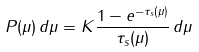<formula> <loc_0><loc_0><loc_500><loc_500>P ( \mu ) \, d \mu = K \frac { 1 - e ^ { - \tau _ { s } ( \mu ) } } { \tau _ { s } ( \mu ) } \, d \mu</formula> 